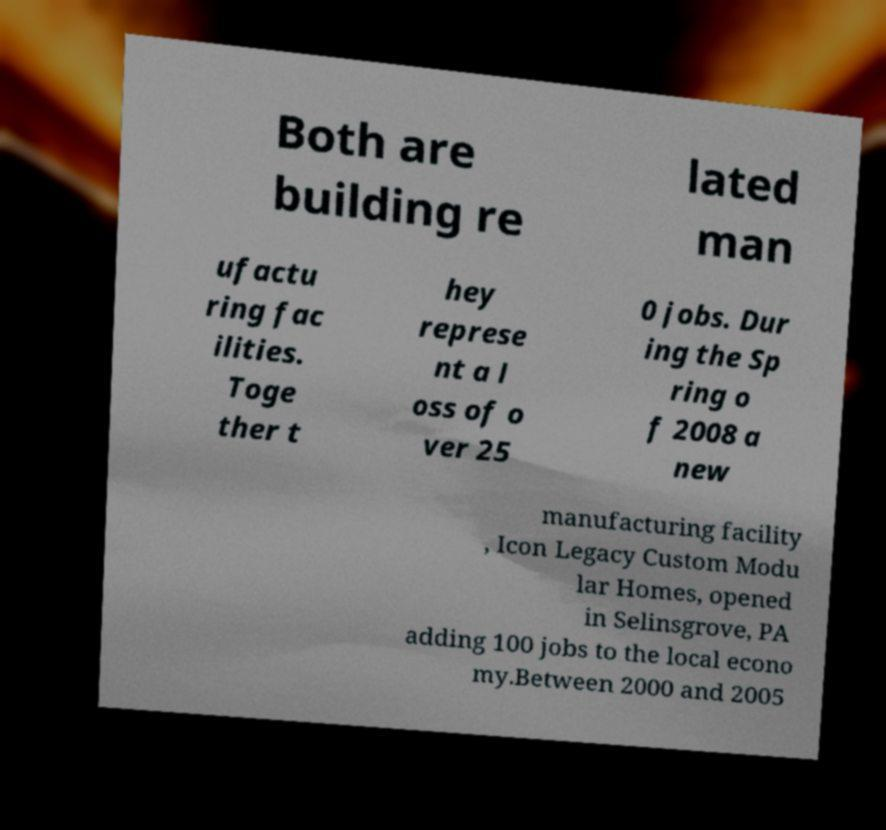Could you extract and type out the text from this image? Both are building re lated man ufactu ring fac ilities. Toge ther t hey represe nt a l oss of o ver 25 0 jobs. Dur ing the Sp ring o f 2008 a new manufacturing facility , Icon Legacy Custom Modu lar Homes, opened in Selinsgrove, PA adding 100 jobs to the local econo my.Between 2000 and 2005 